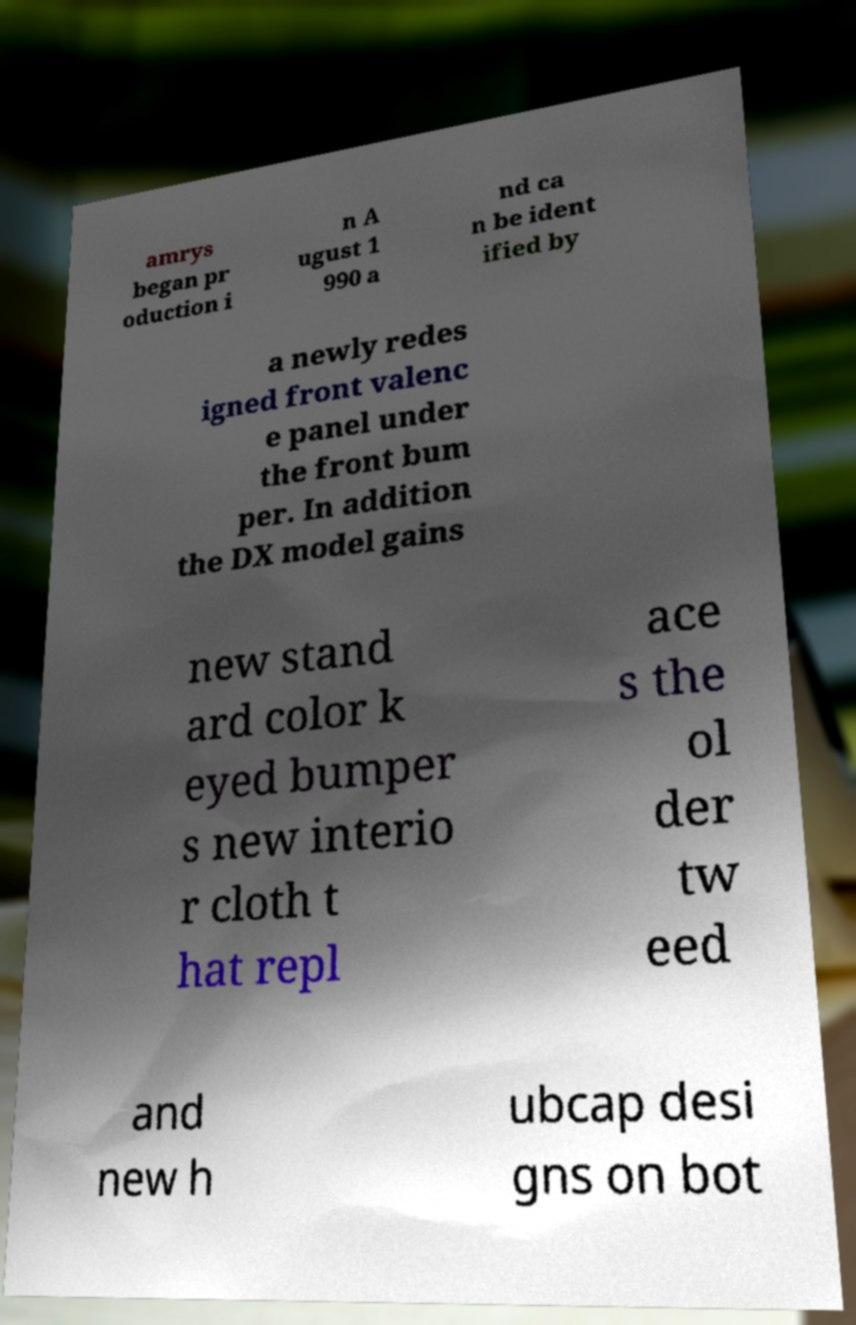Could you assist in decoding the text presented in this image and type it out clearly? amrys began pr oduction i n A ugust 1 990 a nd ca n be ident ified by a newly redes igned front valenc e panel under the front bum per. In addition the DX model gains new stand ard color k eyed bumper s new interio r cloth t hat repl ace s the ol der tw eed and new h ubcap desi gns on bot 